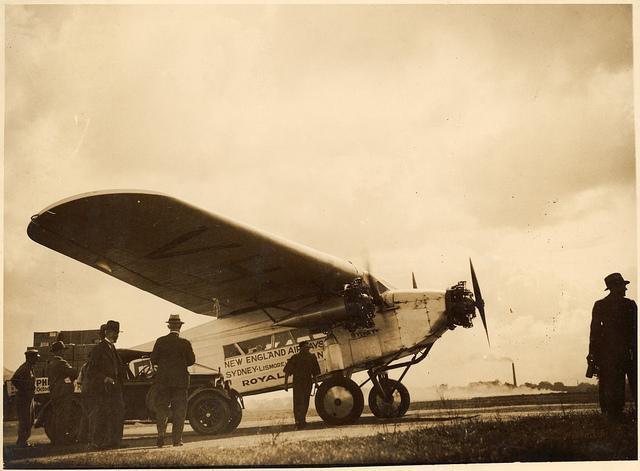How many vehicles are shown?
Give a very brief answer. 2. How many trucks are there?
Give a very brief answer. 1. How many people can you see?
Give a very brief answer. 3. 